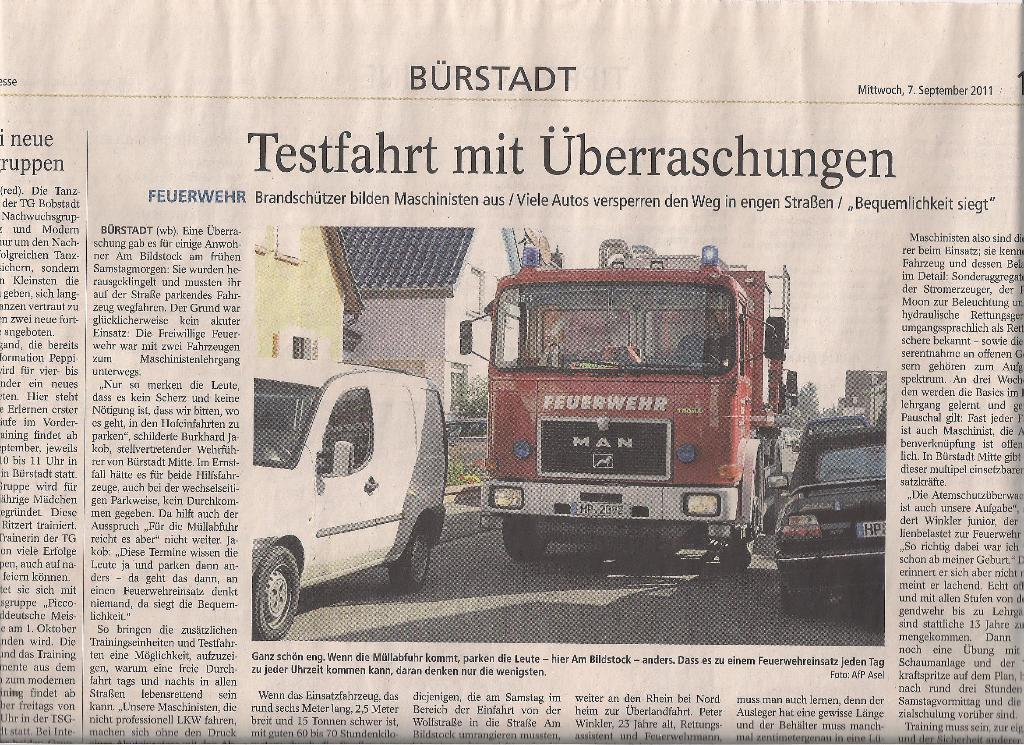What is the main subject in the center of the image? There is a newspaper in the center of the image. What type of content is featured in the newspaper? The newspaper contains images of vehicles. Is there any text present in the newspaper? Yes, the newspaper has text. What type of butter is being used to grease the skate in the image? There is no butter or skate present in the image; it features a newspaper with images of vehicles and text. 